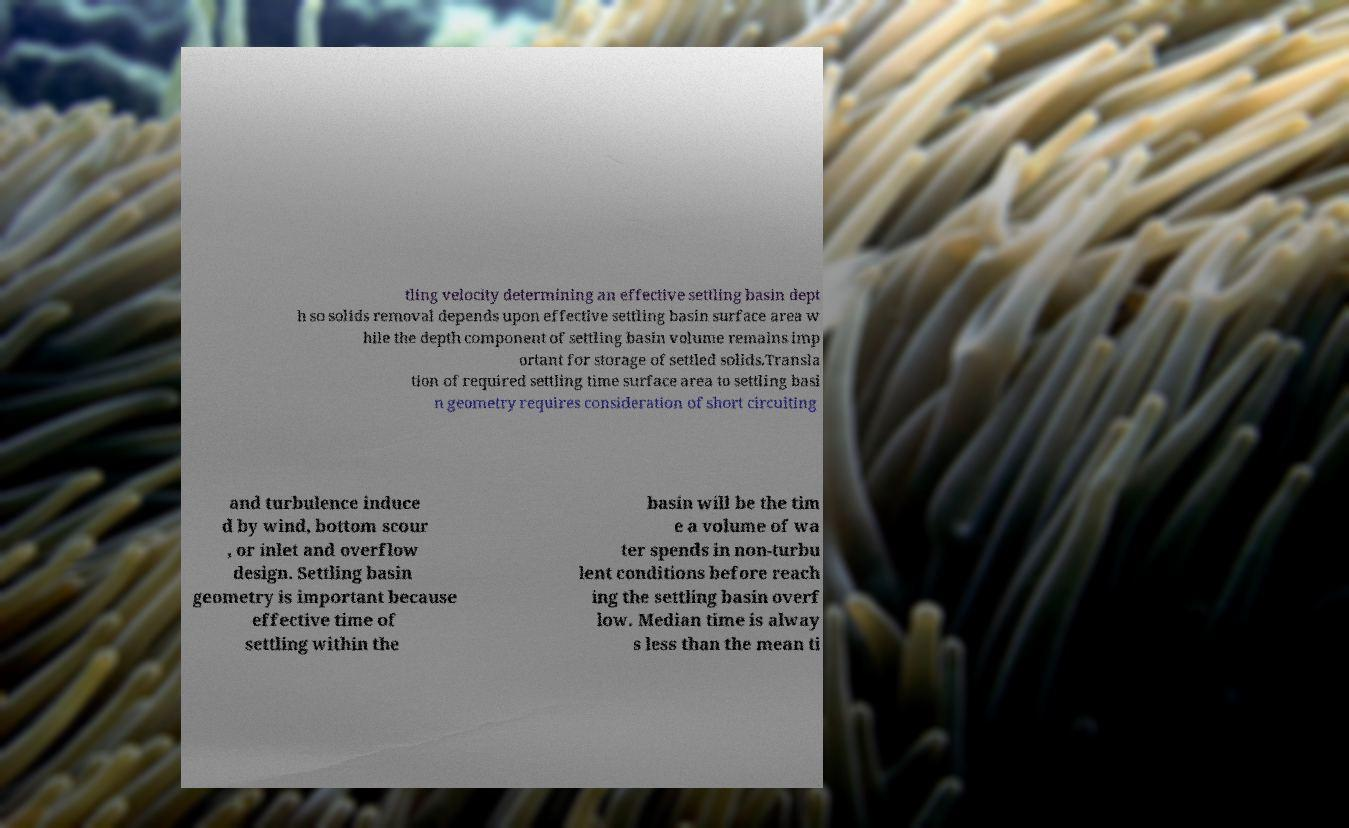There's text embedded in this image that I need extracted. Can you transcribe it verbatim? tling velocity determining an effective settling basin dept h so solids removal depends upon effective settling basin surface area w hile the depth component of settling basin volume remains imp ortant for storage of settled solids.Transla tion of required settling time surface area to settling basi n geometry requires consideration of short circuiting and turbulence induce d by wind, bottom scour , or inlet and overflow design. Settling basin geometry is important because effective time of settling within the basin will be the tim e a volume of wa ter spends in non-turbu lent conditions before reach ing the settling basin overf low. Median time is alway s less than the mean ti 